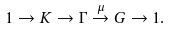<formula> <loc_0><loc_0><loc_500><loc_500>1 \rightarrow K \rightarrow \Gamma \stackrel { \mu } { \rightarrow } G \rightarrow 1 .</formula> 